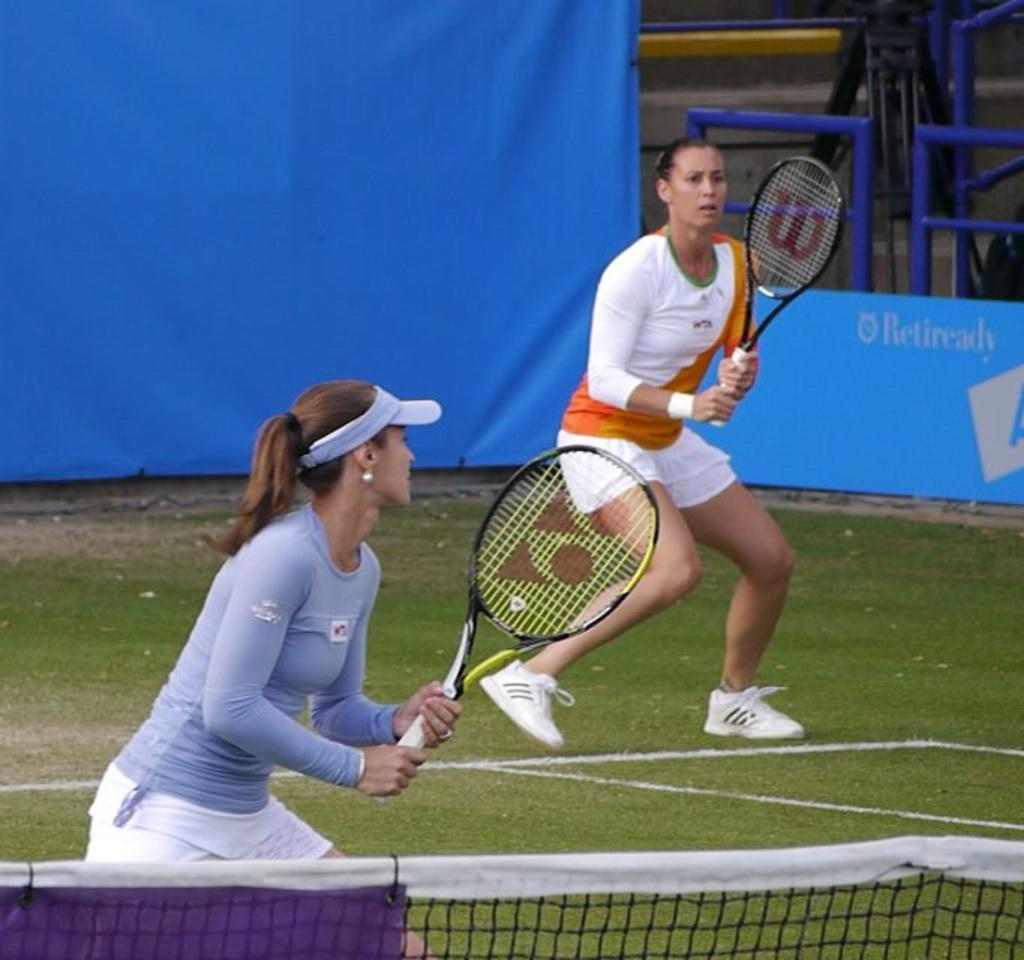What activity are the two women in the image engaged in? The two women are playing tennis. Can you describe the clothing of the woman wearing the white t-shirt? The woman wearing the white t-shirt has an orange stripe on it. What color is the shirt of the other woman? The other woman is wearing a pale blue shirt. What can be seen behind the women in the image? There is a blue color screen behind them. What type of crops is the farmer harvesting in the image? There is no farmer or crops present in the image; it features two women playing tennis. How far does the range extend in the image? There is no range present in the image; it features two women playing tennis in front of a blue color screen. 